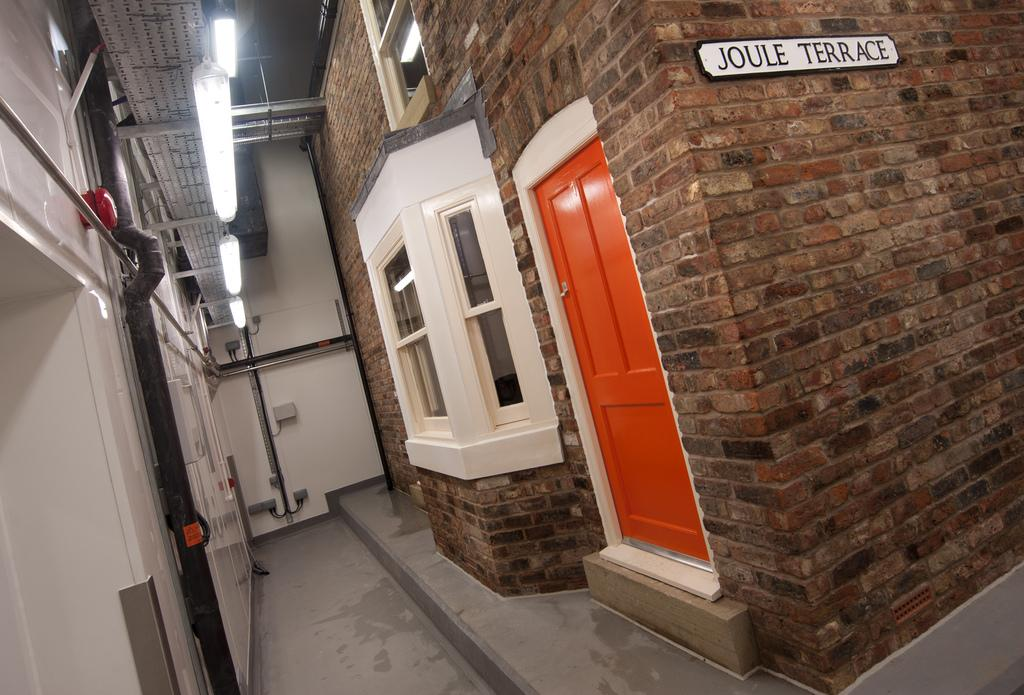What type of structure can be seen in the image? There is a brick wall in the image. What is the purpose of the opening in the brick wall? There is a door in the image, which suggests it is an entrance or exit. Are there any openings for light and ventilation in the brick wall? Yes, there are windows in the image. What is visible beneath the door and windows? The floor is visible in the image. What is used to provide illumination in the image? There are lights in the image. What is attached to the wall in the image? There is a board in the image. What is written or displayed on the board? There is text on the board. How many apples are on the board in the image? There are no apples present in the image; the board has text on it. What does the mom say about the brick wall in the image? There is no mention of a mom or any dialogue in the image. 